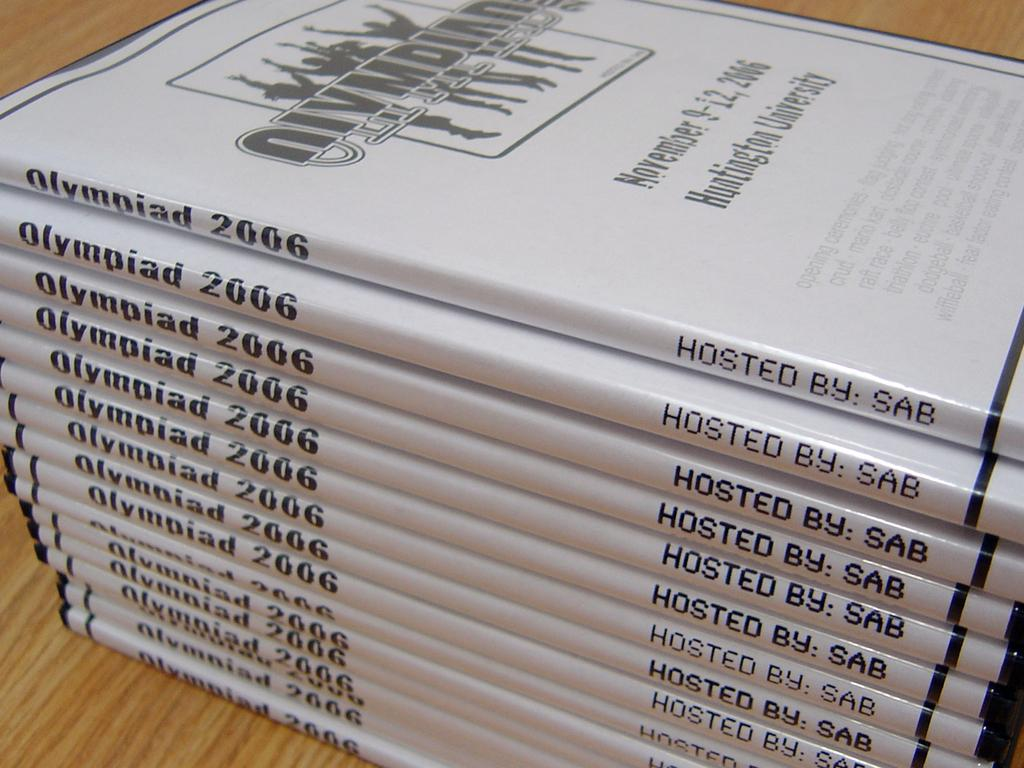<image>
Relay a brief, clear account of the picture shown. Books of the Olympiad that is hosted by sab 